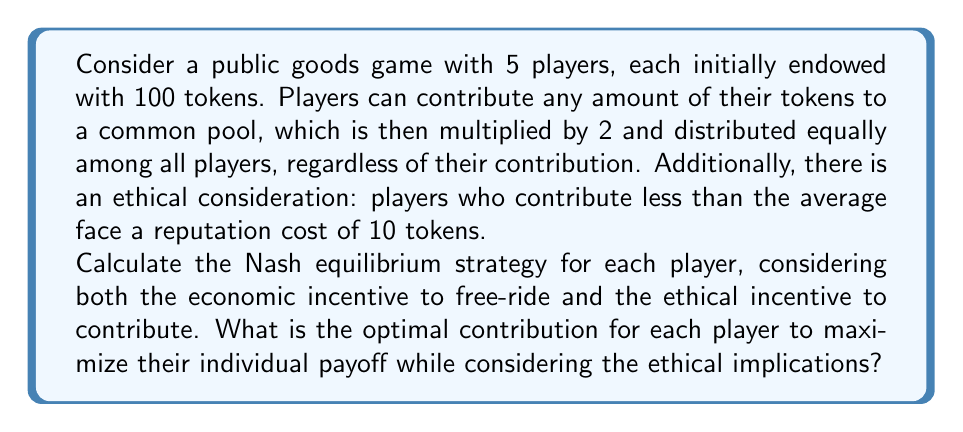Could you help me with this problem? To solve this problem, we need to consider both the economic and ethical aspects of the game:

1) Let's define $x_i$ as the contribution of player $i$, where $i \in \{1, 2, 3, 4, 5\}$.

2) The total contribution to the common pool is $\sum_{i=1}^5 x_i$.

3) After multiplication, the total amount to be distributed is $2\sum_{i=1}^5 x_i$.

4) Each player receives an equal share: $\frac{2\sum_{i=1}^5 x_i}{5}$.

5) The payoff function for each player, without considering the ethical cost, is:

   $$P_i = 100 - x_i + \frac{2\sum_{i=1}^5 x_i}{5}$$

6) The average contribution is $\frac{\sum_{i=1}^5 x_i}{5}$.

7) If a player contributes less than the average, they face a reputation cost of 10 tokens.

8) The complete payoff function, including the ethical consideration, is:

   $$P_i = 100 - x_i + \frac{2\sum_{i=1}^5 x_i}{5} - 10 \cdot I(x_i < \frac{\sum_{i=1}^5 x_i}{5})$$

   where $I()$ is the indicator function.

9) In a Nash equilibrium, all players should have the same strategy due to symmetry. Let's call this common strategy $x$.

10) The payoff function simplifies to:

    $$P = 100 - x + \frac{2(5x)}{5} = 100 - x + 2x = 100 + x$$

11) This function is increasing in $x$, which means players have an incentive to contribute more to avoid the reputation cost.

12) The optimal strategy is for all players to contribute the same amount, just enough to avoid the reputation cost. This occurs when each player contributes exactly the average amount.

13) Therefore, in equilibrium, $x = \frac{\sum_{i=1}^5 x_i}{5} = x$, which is true for any value of $x$.

14) To maximize individual payoff while considering ethical implications, players should coordinate on a common contribution amount. The highest possible contribution that maintains this equilibrium is 100 tokens (the entire endowment).
Answer: The Nash equilibrium strategy is for each player to contribute the same amount $x$, where $0 \leq x \leq 100$. The optimal contribution to maximize individual payoff while considering ethical implications is 100 tokens for each player. 